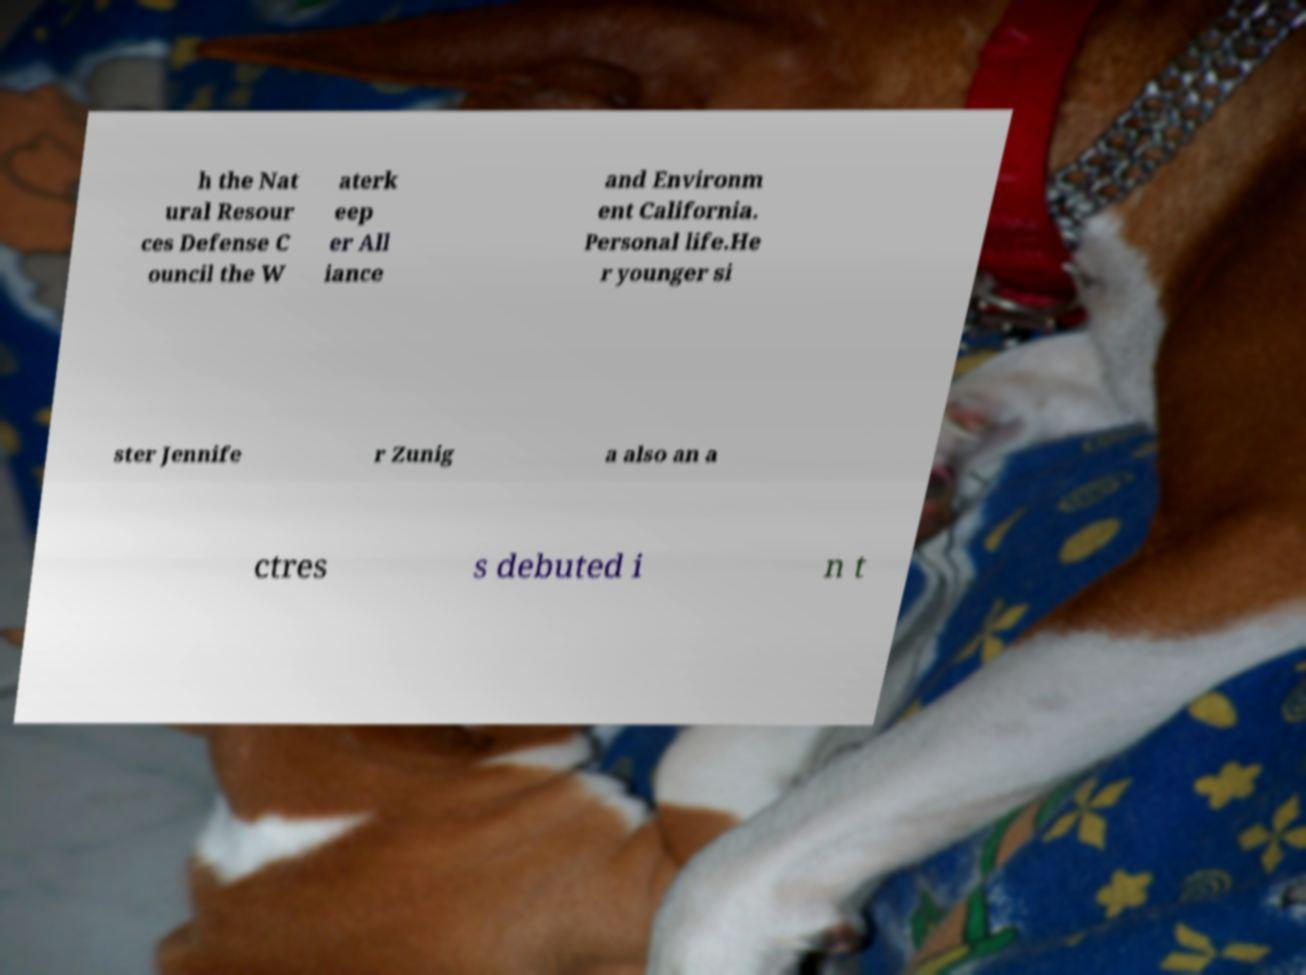Could you extract and type out the text from this image? h the Nat ural Resour ces Defense C ouncil the W aterk eep er All iance and Environm ent California. Personal life.He r younger si ster Jennife r Zunig a also an a ctres s debuted i n t 